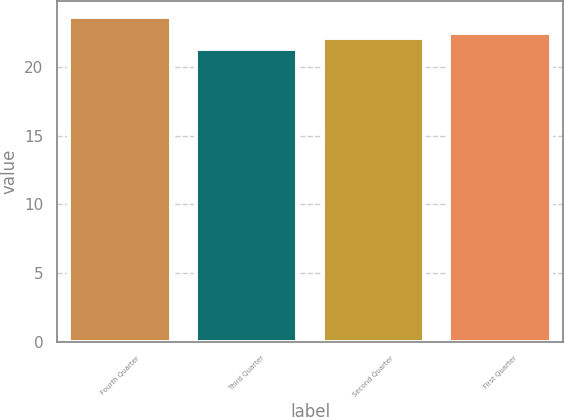<chart> <loc_0><loc_0><loc_500><loc_500><bar_chart><fcel>Fourth Quarter<fcel>Third Quarter<fcel>Second Quarter<fcel>First Quarter<nl><fcel>23.65<fcel>21.3<fcel>22.14<fcel>22.51<nl></chart> 